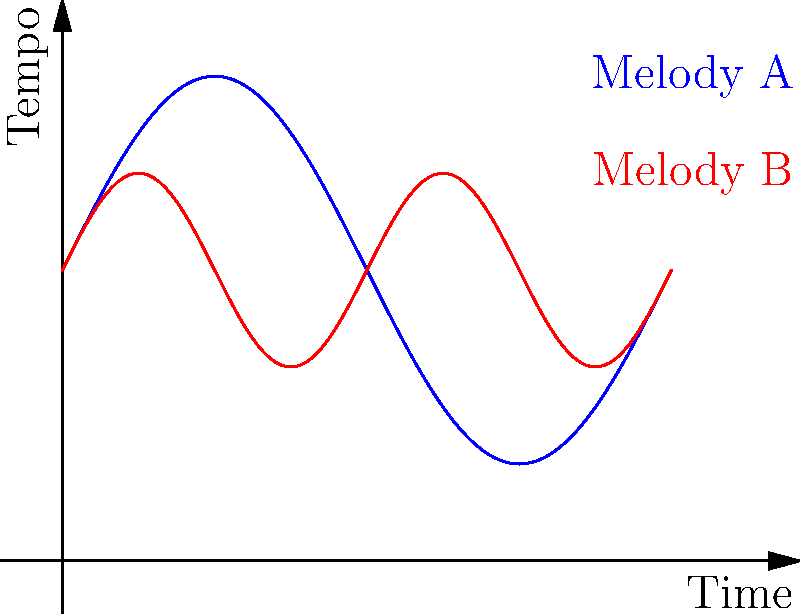In the graph above, two melodies (A and B) are represented by ellipses that visualize their rhythm and tempo changes over time. Melody A is shown in blue, and Melody B is shown in red. Based on this visualization, which melody would likely create a more dynamic and varied musical experience in a theatrical script, and why? To determine which melody would create a more dynamic and varied musical experience, we need to analyze the characteristics of both curves:

1. Melody A (blue curve):
   - Has a longer wavelength, indicating slower rhythm changes.
   - Larger amplitude, suggesting more significant tempo variations.

2. Melody B (red curve):
   - Has a shorter wavelength, indicating faster rhythm changes.
   - Smaller amplitude, suggesting less extreme tempo variations.

3. Comparing the two melodies:
   - Melody A changes more slowly but with greater intensity.
   - Melody B changes more frequently but with less intensity.

4. Impact on theatrical script:
   - Melody A would provide broader, sweeping changes in mood and pacing.
   - Melody B would offer more frequent, subtle variations in energy and rhythm.

5. Dynamic and varied experience:
   - Melody B would likely create a more dynamic and varied experience due to its higher frequency of changes, allowing for more frequent shifts in the script's emotional tone and pacing.

6. Theatrical application:
   - Melody B's frequent variations could better support moment-to-moment changes in dialogue and action.
   - It would provide more opportunities for the playwright to synchronize the script with musical cues and transitions.

Therefore, Melody B (red curve) would likely create a more dynamic and varied musical experience in a theatrical script due to its more frequent rhythm and tempo changes, offering more opportunities for nuanced storytelling and character development.
Answer: Melody B (red curve), due to more frequent rhythm and tempo changes. 